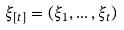<formula> <loc_0><loc_0><loc_500><loc_500>\xi _ { [ t ] } = ( \xi _ { 1 } , \dots , \xi _ { t } )</formula> 